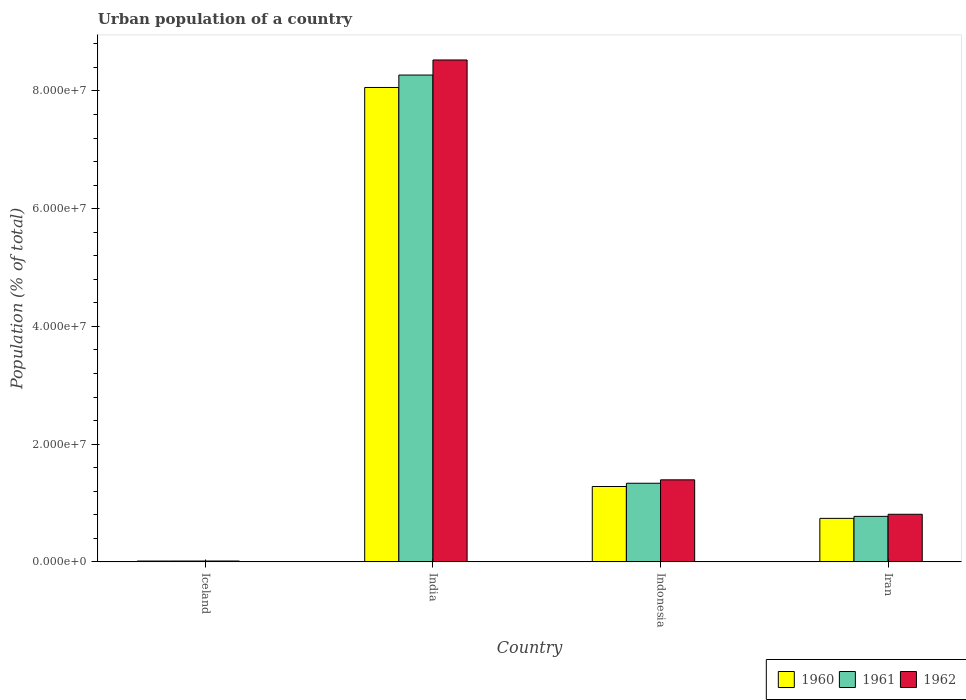How many different coloured bars are there?
Your answer should be compact. 3. Are the number of bars per tick equal to the number of legend labels?
Offer a terse response. Yes. How many bars are there on the 3rd tick from the right?
Give a very brief answer. 3. In how many cases, is the number of bars for a given country not equal to the number of legend labels?
Keep it short and to the point. 0. What is the urban population in 1960 in Iceland?
Offer a very short reply. 1.41e+05. Across all countries, what is the maximum urban population in 1961?
Make the answer very short. 8.27e+07. Across all countries, what is the minimum urban population in 1962?
Make the answer very short. 1.48e+05. In which country was the urban population in 1962 maximum?
Your response must be concise. India. What is the total urban population in 1962 in the graph?
Your answer should be very brief. 1.07e+08. What is the difference between the urban population in 1960 in Iceland and that in India?
Offer a very short reply. -8.05e+07. What is the difference between the urban population in 1961 in Iceland and the urban population in 1960 in Indonesia?
Provide a succinct answer. -1.27e+07. What is the average urban population in 1961 per country?
Keep it short and to the point. 2.60e+07. What is the difference between the urban population of/in 1962 and urban population of/in 1961 in Iceland?
Your response must be concise. 3607. In how many countries, is the urban population in 1960 greater than 64000000 %?
Provide a short and direct response. 1. What is the ratio of the urban population in 1960 in Iceland to that in Indonesia?
Make the answer very short. 0.01. What is the difference between the highest and the second highest urban population in 1960?
Provide a succinct answer. -6.78e+07. What is the difference between the highest and the lowest urban population in 1962?
Your response must be concise. 8.51e+07. Is the sum of the urban population in 1962 in India and Indonesia greater than the maximum urban population in 1960 across all countries?
Your response must be concise. Yes. What does the 2nd bar from the left in India represents?
Offer a terse response. 1961. Is it the case that in every country, the sum of the urban population in 1961 and urban population in 1962 is greater than the urban population in 1960?
Provide a short and direct response. Yes. How many countries are there in the graph?
Keep it short and to the point. 4. What is the difference between two consecutive major ticks on the Y-axis?
Give a very brief answer. 2.00e+07. Are the values on the major ticks of Y-axis written in scientific E-notation?
Offer a terse response. Yes. Does the graph contain grids?
Give a very brief answer. No. Where does the legend appear in the graph?
Provide a short and direct response. Bottom right. What is the title of the graph?
Ensure brevity in your answer.  Urban population of a country. Does "2003" appear as one of the legend labels in the graph?
Offer a terse response. No. What is the label or title of the Y-axis?
Provide a succinct answer. Population (% of total). What is the Population (% of total) of 1960 in Iceland?
Your response must be concise. 1.41e+05. What is the Population (% of total) of 1961 in Iceland?
Offer a very short reply. 1.45e+05. What is the Population (% of total) in 1962 in Iceland?
Your response must be concise. 1.48e+05. What is the Population (% of total) of 1960 in India?
Keep it short and to the point. 8.06e+07. What is the Population (% of total) in 1961 in India?
Make the answer very short. 8.27e+07. What is the Population (% of total) of 1962 in India?
Ensure brevity in your answer.  8.53e+07. What is the Population (% of total) in 1960 in Indonesia?
Provide a short and direct response. 1.28e+07. What is the Population (% of total) of 1961 in Indonesia?
Provide a succinct answer. 1.34e+07. What is the Population (% of total) of 1962 in Indonesia?
Offer a terse response. 1.39e+07. What is the Population (% of total) in 1960 in Iran?
Keep it short and to the point. 7.39e+06. What is the Population (% of total) of 1961 in Iran?
Offer a very short reply. 7.73e+06. What is the Population (% of total) of 1962 in Iran?
Your answer should be compact. 8.09e+06. Across all countries, what is the maximum Population (% of total) in 1960?
Offer a very short reply. 8.06e+07. Across all countries, what is the maximum Population (% of total) in 1961?
Offer a very short reply. 8.27e+07. Across all countries, what is the maximum Population (% of total) of 1962?
Offer a very short reply. 8.53e+07. Across all countries, what is the minimum Population (% of total) in 1960?
Offer a terse response. 1.41e+05. Across all countries, what is the minimum Population (% of total) of 1961?
Make the answer very short. 1.45e+05. Across all countries, what is the minimum Population (% of total) in 1962?
Make the answer very short. 1.48e+05. What is the total Population (% of total) of 1960 in the graph?
Your answer should be very brief. 1.01e+08. What is the total Population (% of total) in 1961 in the graph?
Give a very brief answer. 1.04e+08. What is the total Population (% of total) of 1962 in the graph?
Your answer should be very brief. 1.07e+08. What is the difference between the Population (% of total) of 1960 in Iceland and that in India?
Your answer should be very brief. -8.05e+07. What is the difference between the Population (% of total) of 1961 in Iceland and that in India?
Offer a very short reply. -8.26e+07. What is the difference between the Population (% of total) of 1962 in Iceland and that in India?
Offer a very short reply. -8.51e+07. What is the difference between the Population (% of total) of 1960 in Iceland and that in Indonesia?
Keep it short and to the point. -1.27e+07. What is the difference between the Population (% of total) in 1961 in Iceland and that in Indonesia?
Ensure brevity in your answer.  -1.32e+07. What is the difference between the Population (% of total) in 1962 in Iceland and that in Indonesia?
Provide a succinct answer. -1.38e+07. What is the difference between the Population (% of total) in 1960 in Iceland and that in Iran?
Offer a terse response. -7.25e+06. What is the difference between the Population (% of total) in 1961 in Iceland and that in Iran?
Your response must be concise. -7.59e+06. What is the difference between the Population (% of total) in 1962 in Iceland and that in Iran?
Your answer should be very brief. -7.94e+06. What is the difference between the Population (% of total) in 1960 in India and that in Indonesia?
Offer a terse response. 6.78e+07. What is the difference between the Population (% of total) of 1961 in India and that in Indonesia?
Offer a terse response. 6.94e+07. What is the difference between the Population (% of total) of 1962 in India and that in Indonesia?
Offer a terse response. 7.13e+07. What is the difference between the Population (% of total) of 1960 in India and that in Iran?
Offer a very short reply. 7.32e+07. What is the difference between the Population (% of total) in 1961 in India and that in Iran?
Offer a very short reply. 7.50e+07. What is the difference between the Population (% of total) of 1962 in India and that in Iran?
Ensure brevity in your answer.  7.72e+07. What is the difference between the Population (% of total) in 1960 in Indonesia and that in Iran?
Give a very brief answer. 5.42e+06. What is the difference between the Population (% of total) of 1961 in Indonesia and that in Iran?
Provide a short and direct response. 5.63e+06. What is the difference between the Population (% of total) in 1962 in Indonesia and that in Iran?
Provide a short and direct response. 5.85e+06. What is the difference between the Population (% of total) in 1960 in Iceland and the Population (% of total) in 1961 in India?
Offer a very short reply. -8.26e+07. What is the difference between the Population (% of total) in 1960 in Iceland and the Population (% of total) in 1962 in India?
Provide a succinct answer. -8.51e+07. What is the difference between the Population (% of total) in 1961 in Iceland and the Population (% of total) in 1962 in India?
Keep it short and to the point. -8.51e+07. What is the difference between the Population (% of total) in 1960 in Iceland and the Population (% of total) in 1961 in Indonesia?
Your answer should be compact. -1.32e+07. What is the difference between the Population (% of total) of 1960 in Iceland and the Population (% of total) of 1962 in Indonesia?
Provide a succinct answer. -1.38e+07. What is the difference between the Population (% of total) of 1961 in Iceland and the Population (% of total) of 1962 in Indonesia?
Your answer should be very brief. -1.38e+07. What is the difference between the Population (% of total) in 1960 in Iceland and the Population (% of total) in 1961 in Iran?
Offer a terse response. -7.59e+06. What is the difference between the Population (% of total) of 1960 in Iceland and the Population (% of total) of 1962 in Iran?
Provide a succinct answer. -7.95e+06. What is the difference between the Population (% of total) of 1961 in Iceland and the Population (% of total) of 1962 in Iran?
Offer a very short reply. -7.94e+06. What is the difference between the Population (% of total) in 1960 in India and the Population (% of total) in 1961 in Indonesia?
Provide a short and direct response. 6.72e+07. What is the difference between the Population (% of total) in 1960 in India and the Population (% of total) in 1962 in Indonesia?
Provide a succinct answer. 6.67e+07. What is the difference between the Population (% of total) in 1961 in India and the Population (% of total) in 1962 in Indonesia?
Your response must be concise. 6.88e+07. What is the difference between the Population (% of total) in 1960 in India and the Population (% of total) in 1961 in Iran?
Provide a succinct answer. 7.29e+07. What is the difference between the Population (% of total) in 1960 in India and the Population (% of total) in 1962 in Iran?
Offer a very short reply. 7.25e+07. What is the difference between the Population (% of total) of 1961 in India and the Population (% of total) of 1962 in Iran?
Provide a succinct answer. 7.46e+07. What is the difference between the Population (% of total) of 1960 in Indonesia and the Population (% of total) of 1961 in Iran?
Offer a very short reply. 5.07e+06. What is the difference between the Population (% of total) of 1960 in Indonesia and the Population (% of total) of 1962 in Iran?
Make the answer very short. 4.72e+06. What is the difference between the Population (% of total) of 1961 in Indonesia and the Population (% of total) of 1962 in Iran?
Provide a short and direct response. 5.27e+06. What is the average Population (% of total) in 1960 per country?
Provide a short and direct response. 2.52e+07. What is the average Population (% of total) of 1961 per country?
Your answer should be very brief. 2.60e+07. What is the average Population (% of total) of 1962 per country?
Your response must be concise. 2.69e+07. What is the difference between the Population (% of total) in 1960 and Population (% of total) in 1961 in Iceland?
Ensure brevity in your answer.  -3675. What is the difference between the Population (% of total) in 1960 and Population (% of total) in 1962 in Iceland?
Provide a short and direct response. -7282. What is the difference between the Population (% of total) in 1961 and Population (% of total) in 1962 in Iceland?
Offer a very short reply. -3607. What is the difference between the Population (% of total) in 1960 and Population (% of total) in 1961 in India?
Your answer should be compact. -2.11e+06. What is the difference between the Population (% of total) of 1960 and Population (% of total) of 1962 in India?
Provide a succinct answer. -4.67e+06. What is the difference between the Population (% of total) of 1961 and Population (% of total) of 1962 in India?
Your answer should be compact. -2.56e+06. What is the difference between the Population (% of total) of 1960 and Population (% of total) of 1961 in Indonesia?
Provide a succinct answer. -5.54e+05. What is the difference between the Population (% of total) in 1960 and Population (% of total) in 1962 in Indonesia?
Offer a very short reply. -1.13e+06. What is the difference between the Population (% of total) in 1961 and Population (% of total) in 1962 in Indonesia?
Provide a succinct answer. -5.78e+05. What is the difference between the Population (% of total) of 1960 and Population (% of total) of 1961 in Iran?
Offer a very short reply. -3.40e+05. What is the difference between the Population (% of total) of 1960 and Population (% of total) of 1962 in Iran?
Give a very brief answer. -6.96e+05. What is the difference between the Population (% of total) in 1961 and Population (% of total) in 1962 in Iran?
Your answer should be compact. -3.56e+05. What is the ratio of the Population (% of total) in 1960 in Iceland to that in India?
Keep it short and to the point. 0. What is the ratio of the Population (% of total) in 1961 in Iceland to that in India?
Offer a very short reply. 0. What is the ratio of the Population (% of total) of 1962 in Iceland to that in India?
Your answer should be very brief. 0. What is the ratio of the Population (% of total) of 1960 in Iceland to that in Indonesia?
Offer a terse response. 0.01. What is the ratio of the Population (% of total) in 1961 in Iceland to that in Indonesia?
Ensure brevity in your answer.  0.01. What is the ratio of the Population (% of total) in 1962 in Iceland to that in Indonesia?
Your answer should be compact. 0.01. What is the ratio of the Population (% of total) in 1960 in Iceland to that in Iran?
Provide a short and direct response. 0.02. What is the ratio of the Population (% of total) of 1961 in Iceland to that in Iran?
Keep it short and to the point. 0.02. What is the ratio of the Population (% of total) in 1962 in Iceland to that in Iran?
Give a very brief answer. 0.02. What is the ratio of the Population (% of total) in 1960 in India to that in Indonesia?
Provide a short and direct response. 6.29. What is the ratio of the Population (% of total) of 1961 in India to that in Indonesia?
Give a very brief answer. 6.19. What is the ratio of the Population (% of total) in 1962 in India to that in Indonesia?
Provide a short and direct response. 6.12. What is the ratio of the Population (% of total) in 1960 in India to that in Iran?
Keep it short and to the point. 10.91. What is the ratio of the Population (% of total) of 1961 in India to that in Iran?
Make the answer very short. 10.7. What is the ratio of the Population (% of total) in 1962 in India to that in Iran?
Your response must be concise. 10.54. What is the ratio of the Population (% of total) in 1960 in Indonesia to that in Iran?
Your answer should be compact. 1.73. What is the ratio of the Population (% of total) in 1961 in Indonesia to that in Iran?
Give a very brief answer. 1.73. What is the ratio of the Population (% of total) in 1962 in Indonesia to that in Iran?
Your answer should be compact. 1.72. What is the difference between the highest and the second highest Population (% of total) in 1960?
Your answer should be very brief. 6.78e+07. What is the difference between the highest and the second highest Population (% of total) in 1961?
Give a very brief answer. 6.94e+07. What is the difference between the highest and the second highest Population (% of total) in 1962?
Your answer should be very brief. 7.13e+07. What is the difference between the highest and the lowest Population (% of total) in 1960?
Keep it short and to the point. 8.05e+07. What is the difference between the highest and the lowest Population (% of total) of 1961?
Ensure brevity in your answer.  8.26e+07. What is the difference between the highest and the lowest Population (% of total) of 1962?
Offer a very short reply. 8.51e+07. 